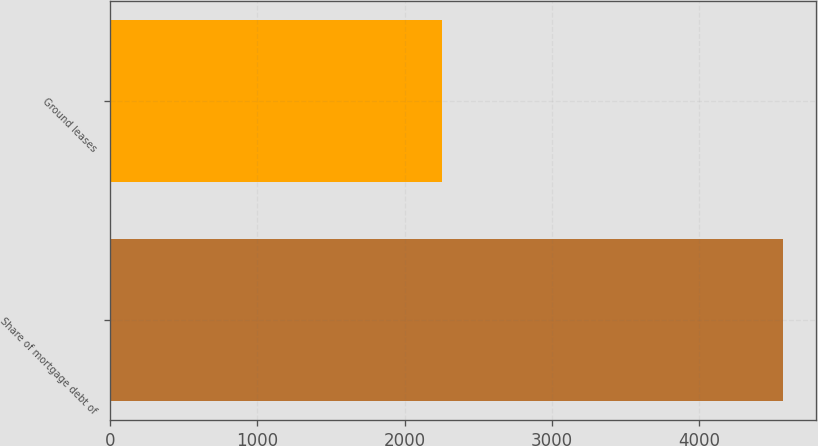Convert chart to OTSL. <chart><loc_0><loc_0><loc_500><loc_500><bar_chart><fcel>Share of mortgage debt of<fcel>Ground leases<nl><fcel>4567<fcel>2252<nl></chart> 